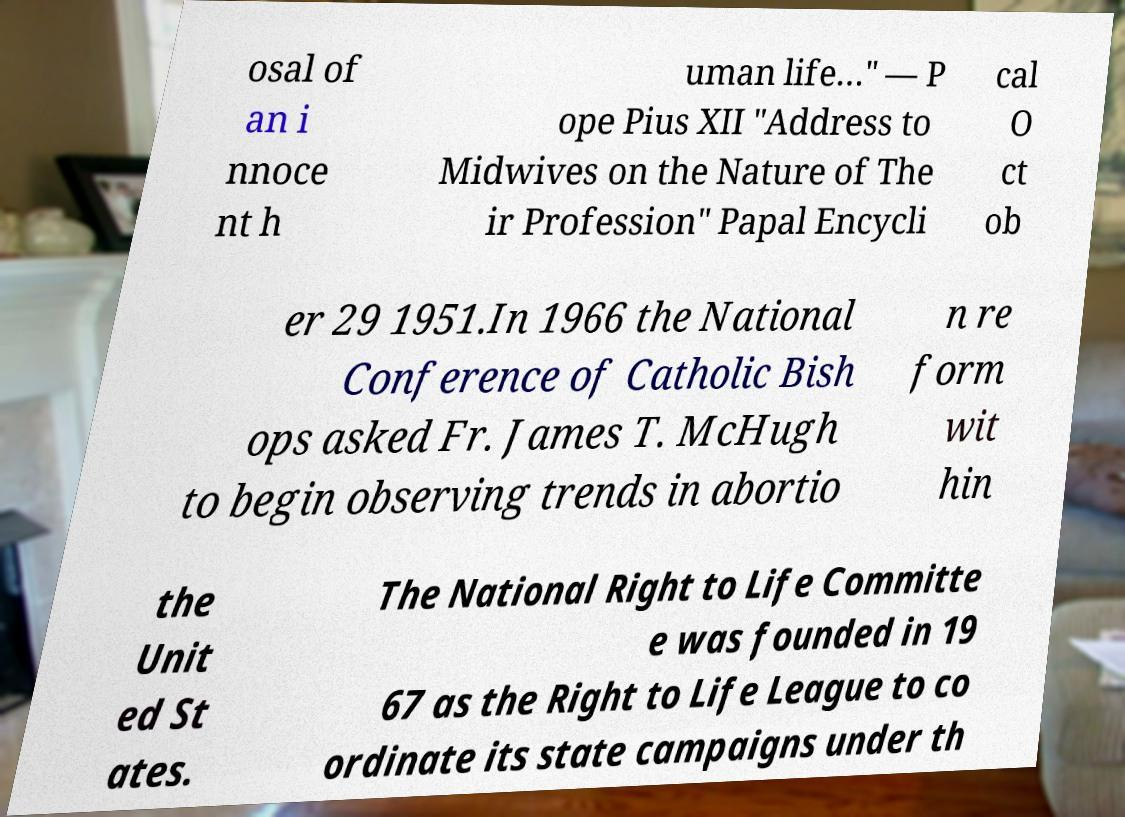Could you assist in decoding the text presented in this image and type it out clearly? osal of an i nnoce nt h uman life…" — P ope Pius XII "Address to Midwives on the Nature of The ir Profession" Papal Encycli cal O ct ob er 29 1951.In 1966 the National Conference of Catholic Bish ops asked Fr. James T. McHugh to begin observing trends in abortio n re form wit hin the Unit ed St ates. The National Right to Life Committe e was founded in 19 67 as the Right to Life League to co ordinate its state campaigns under th 